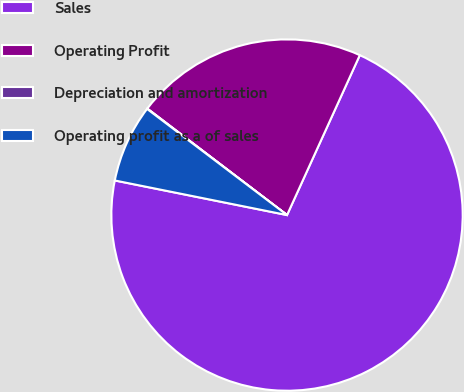Convert chart to OTSL. <chart><loc_0><loc_0><loc_500><loc_500><pie_chart><fcel>Sales<fcel>Operating Profit<fcel>Depreciation and amortization<fcel>Operating profit as a of sales<nl><fcel>71.35%<fcel>21.43%<fcel>0.04%<fcel>7.17%<nl></chart> 